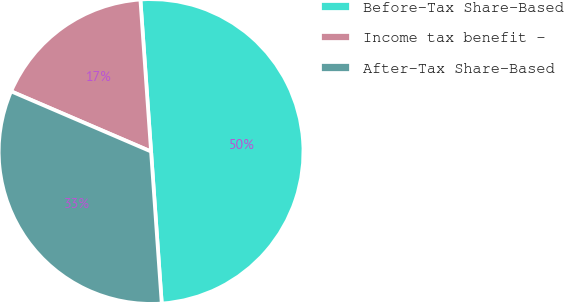Convert chart. <chart><loc_0><loc_0><loc_500><loc_500><pie_chart><fcel>Before-Tax Share-Based<fcel>Income tax benefit -<fcel>After-Tax Share-Based<nl><fcel>50.0%<fcel>17.42%<fcel>32.58%<nl></chart> 